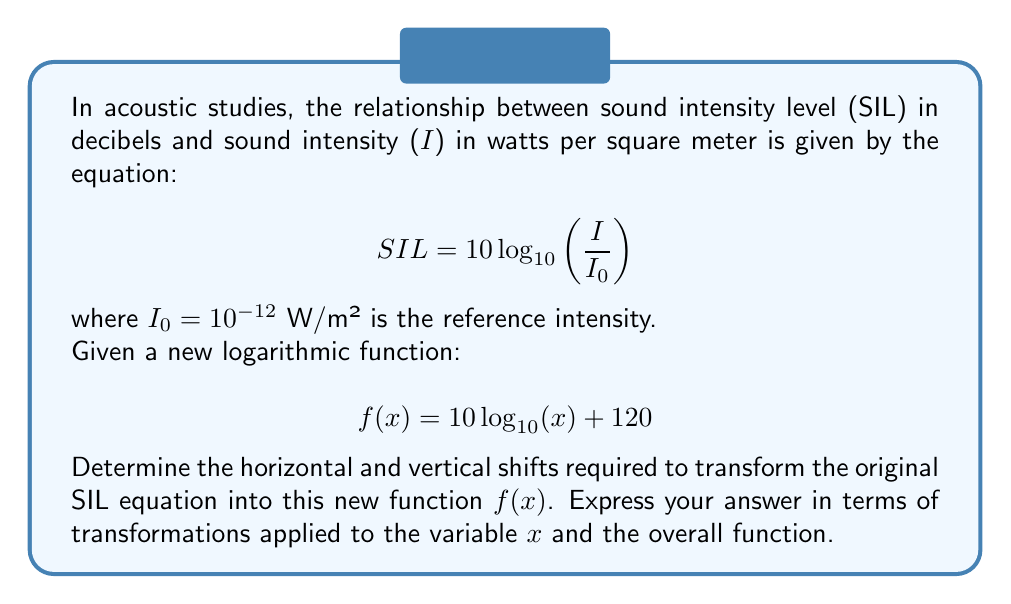What is the answer to this math problem? To solve this problem, we need to compare the original SIL equation with the new function $f(x)$ and identify the transformations applied. Let's approach this step-by-step:

1) First, let's rewrite the original SIL equation:

   $$ SIL = 10 \log_{10}\left(\frac{I}{I_0}\right) $$

2) Expand this using the properties of logarithms:

   $$ SIL = 10 \log_{10}(I) - 10 \log_{10}(I_0) $$

3) Since $I_0 = 10^{-12}$, we can calculate $10 \log_{10}(I_0)$:

   $$ 10 \log_{10}(I_0) = 10 \log_{10}(10^{-12}) = 10 \cdot (-12) = -120 $$

4) Substituting this back into the equation:

   $$ SIL = 10 \log_{10}(I) + 120 $$

5) Now, compare this with the new function:

   $$ f(x) = 10 \log_{10}(x) + 120 $$

6) We can see that $f(x)$ is equivalent to the SIL equation when $x = I$. This means there is no horizontal shift applied to the input variable.

7) The vertical shift is already present in both equations as $+120$.

Therefore, to transform the original SIL equation into $f(x)$, we only need to replace $I$ with $x$, which doesn't constitute a shift in the mathematical sense. The vertical shift of $+120$ is already present in both equations.
Answer: Horizontal shift: None
Vertical shift: $+120$ (already present in both equations) 